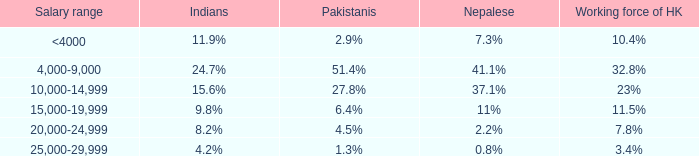Given that 37.1% is the nepalese proportion, what is the total labor force in hong kong? 23%. 